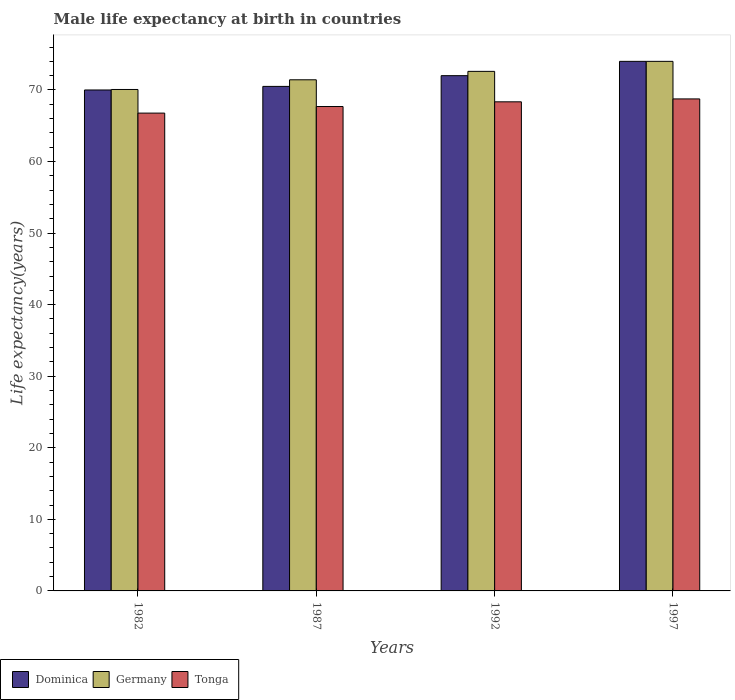How many different coloured bars are there?
Make the answer very short. 3. Are the number of bars per tick equal to the number of legend labels?
Offer a very short reply. Yes. What is the male life expectancy at birth in Dominica in 1987?
Keep it short and to the point. 70.5. Across all years, what is the minimum male life expectancy at birth in Germany?
Give a very brief answer. 70.07. In which year was the male life expectancy at birth in Dominica minimum?
Offer a very short reply. 1982. What is the total male life expectancy at birth in Tonga in the graph?
Offer a terse response. 271.55. What is the difference between the male life expectancy at birth in Germany in 1982 and the male life expectancy at birth in Tonga in 1987?
Give a very brief answer. 2.38. What is the average male life expectancy at birth in Dominica per year?
Ensure brevity in your answer.  71.62. In the year 1992, what is the difference between the male life expectancy at birth in Germany and male life expectancy at birth in Tonga?
Give a very brief answer. 4.25. What is the ratio of the male life expectancy at birth in Tonga in 1987 to that in 1992?
Your response must be concise. 0.99. Is the male life expectancy at birth in Dominica in 1992 less than that in 1997?
Provide a short and direct response. Yes. What is the difference between the highest and the second highest male life expectancy at birth in Germany?
Your answer should be compact. 1.4. What is the difference between the highest and the lowest male life expectancy at birth in Germany?
Your answer should be very brief. 3.93. What does the 1st bar from the left in 1982 represents?
Your answer should be compact. Dominica. How many bars are there?
Make the answer very short. 12. How many years are there in the graph?
Your answer should be very brief. 4. What is the difference between two consecutive major ticks on the Y-axis?
Your response must be concise. 10. Are the values on the major ticks of Y-axis written in scientific E-notation?
Provide a succinct answer. No. Does the graph contain any zero values?
Your answer should be very brief. No. Where does the legend appear in the graph?
Provide a succinct answer. Bottom left. How many legend labels are there?
Offer a terse response. 3. How are the legend labels stacked?
Make the answer very short. Horizontal. What is the title of the graph?
Your answer should be compact. Male life expectancy at birth in countries. What is the label or title of the Y-axis?
Provide a succinct answer. Life expectancy(years). What is the Life expectancy(years) of Germany in 1982?
Ensure brevity in your answer.  70.07. What is the Life expectancy(years) in Tonga in 1982?
Keep it short and to the point. 66.77. What is the Life expectancy(years) in Dominica in 1987?
Your response must be concise. 70.5. What is the Life expectancy(years) of Germany in 1987?
Offer a very short reply. 71.42. What is the Life expectancy(years) of Tonga in 1987?
Make the answer very short. 67.69. What is the Life expectancy(years) in Germany in 1992?
Ensure brevity in your answer.  72.6. What is the Life expectancy(years) in Tonga in 1992?
Give a very brief answer. 68.35. What is the Life expectancy(years) in Dominica in 1997?
Offer a very short reply. 74. What is the Life expectancy(years) of Tonga in 1997?
Your answer should be compact. 68.75. Across all years, what is the maximum Life expectancy(years) of Germany?
Provide a short and direct response. 74. Across all years, what is the maximum Life expectancy(years) of Tonga?
Your response must be concise. 68.75. Across all years, what is the minimum Life expectancy(years) of Dominica?
Make the answer very short. 70. Across all years, what is the minimum Life expectancy(years) of Germany?
Provide a short and direct response. 70.07. Across all years, what is the minimum Life expectancy(years) of Tonga?
Offer a terse response. 66.77. What is the total Life expectancy(years) in Dominica in the graph?
Your response must be concise. 286.5. What is the total Life expectancy(years) in Germany in the graph?
Ensure brevity in your answer.  288.09. What is the total Life expectancy(years) of Tonga in the graph?
Offer a very short reply. 271.56. What is the difference between the Life expectancy(years) in Germany in 1982 and that in 1987?
Give a very brief answer. -1.35. What is the difference between the Life expectancy(years) in Tonga in 1982 and that in 1987?
Offer a very short reply. -0.92. What is the difference between the Life expectancy(years) of Dominica in 1982 and that in 1992?
Provide a short and direct response. -2. What is the difference between the Life expectancy(years) in Germany in 1982 and that in 1992?
Provide a succinct answer. -2.53. What is the difference between the Life expectancy(years) in Tonga in 1982 and that in 1992?
Ensure brevity in your answer.  -1.58. What is the difference between the Life expectancy(years) of Dominica in 1982 and that in 1997?
Keep it short and to the point. -4. What is the difference between the Life expectancy(years) in Germany in 1982 and that in 1997?
Your answer should be compact. -3.93. What is the difference between the Life expectancy(years) in Tonga in 1982 and that in 1997?
Your answer should be compact. -1.98. What is the difference between the Life expectancy(years) of Germany in 1987 and that in 1992?
Offer a terse response. -1.18. What is the difference between the Life expectancy(years) of Tonga in 1987 and that in 1992?
Provide a short and direct response. -0.66. What is the difference between the Life expectancy(years) of Germany in 1987 and that in 1997?
Make the answer very short. -2.58. What is the difference between the Life expectancy(years) of Tonga in 1987 and that in 1997?
Your answer should be compact. -1.06. What is the difference between the Life expectancy(years) of Dominica in 1992 and that in 1997?
Give a very brief answer. -2. What is the difference between the Life expectancy(years) in Germany in 1992 and that in 1997?
Offer a terse response. -1.4. What is the difference between the Life expectancy(years) in Tonga in 1992 and that in 1997?
Offer a very short reply. -0.41. What is the difference between the Life expectancy(years) in Dominica in 1982 and the Life expectancy(years) in Germany in 1987?
Your response must be concise. -1.42. What is the difference between the Life expectancy(years) in Dominica in 1982 and the Life expectancy(years) in Tonga in 1987?
Ensure brevity in your answer.  2.31. What is the difference between the Life expectancy(years) of Germany in 1982 and the Life expectancy(years) of Tonga in 1987?
Keep it short and to the point. 2.38. What is the difference between the Life expectancy(years) in Dominica in 1982 and the Life expectancy(years) in Germany in 1992?
Keep it short and to the point. -2.6. What is the difference between the Life expectancy(years) in Dominica in 1982 and the Life expectancy(years) in Tonga in 1992?
Make the answer very short. 1.65. What is the difference between the Life expectancy(years) of Germany in 1982 and the Life expectancy(years) of Tonga in 1992?
Make the answer very short. 1.72. What is the difference between the Life expectancy(years) in Dominica in 1982 and the Life expectancy(years) in Tonga in 1997?
Ensure brevity in your answer.  1.25. What is the difference between the Life expectancy(years) of Germany in 1982 and the Life expectancy(years) of Tonga in 1997?
Your response must be concise. 1.32. What is the difference between the Life expectancy(years) in Dominica in 1987 and the Life expectancy(years) in Germany in 1992?
Give a very brief answer. -2.1. What is the difference between the Life expectancy(years) of Dominica in 1987 and the Life expectancy(years) of Tonga in 1992?
Your response must be concise. 2.15. What is the difference between the Life expectancy(years) in Germany in 1987 and the Life expectancy(years) in Tonga in 1992?
Offer a terse response. 3.08. What is the difference between the Life expectancy(years) in Dominica in 1987 and the Life expectancy(years) in Tonga in 1997?
Keep it short and to the point. 1.75. What is the difference between the Life expectancy(years) in Germany in 1987 and the Life expectancy(years) in Tonga in 1997?
Your answer should be compact. 2.67. What is the difference between the Life expectancy(years) of Dominica in 1992 and the Life expectancy(years) of Germany in 1997?
Offer a terse response. -2. What is the difference between the Life expectancy(years) of Dominica in 1992 and the Life expectancy(years) of Tonga in 1997?
Provide a succinct answer. 3.25. What is the difference between the Life expectancy(years) of Germany in 1992 and the Life expectancy(years) of Tonga in 1997?
Make the answer very short. 3.85. What is the average Life expectancy(years) of Dominica per year?
Give a very brief answer. 71.62. What is the average Life expectancy(years) in Germany per year?
Offer a very short reply. 72.02. What is the average Life expectancy(years) of Tonga per year?
Keep it short and to the point. 67.89. In the year 1982, what is the difference between the Life expectancy(years) in Dominica and Life expectancy(years) in Germany?
Offer a very short reply. -0.07. In the year 1982, what is the difference between the Life expectancy(years) in Dominica and Life expectancy(years) in Tonga?
Your answer should be very brief. 3.23. In the year 1982, what is the difference between the Life expectancy(years) in Germany and Life expectancy(years) in Tonga?
Offer a very short reply. 3.3. In the year 1987, what is the difference between the Life expectancy(years) of Dominica and Life expectancy(years) of Germany?
Keep it short and to the point. -0.92. In the year 1987, what is the difference between the Life expectancy(years) of Dominica and Life expectancy(years) of Tonga?
Give a very brief answer. 2.81. In the year 1987, what is the difference between the Life expectancy(years) in Germany and Life expectancy(years) in Tonga?
Your response must be concise. 3.73. In the year 1992, what is the difference between the Life expectancy(years) of Dominica and Life expectancy(years) of Germany?
Offer a terse response. -0.6. In the year 1992, what is the difference between the Life expectancy(years) of Dominica and Life expectancy(years) of Tonga?
Make the answer very short. 3.65. In the year 1992, what is the difference between the Life expectancy(years) of Germany and Life expectancy(years) of Tonga?
Your answer should be very brief. 4.25. In the year 1997, what is the difference between the Life expectancy(years) in Dominica and Life expectancy(years) in Tonga?
Ensure brevity in your answer.  5.25. In the year 1997, what is the difference between the Life expectancy(years) in Germany and Life expectancy(years) in Tonga?
Keep it short and to the point. 5.25. What is the ratio of the Life expectancy(years) in Dominica in 1982 to that in 1987?
Offer a terse response. 0.99. What is the ratio of the Life expectancy(years) of Germany in 1982 to that in 1987?
Keep it short and to the point. 0.98. What is the ratio of the Life expectancy(years) of Tonga in 1982 to that in 1987?
Ensure brevity in your answer.  0.99. What is the ratio of the Life expectancy(years) of Dominica in 1982 to that in 1992?
Your answer should be very brief. 0.97. What is the ratio of the Life expectancy(years) of Germany in 1982 to that in 1992?
Give a very brief answer. 0.97. What is the ratio of the Life expectancy(years) in Tonga in 1982 to that in 1992?
Give a very brief answer. 0.98. What is the ratio of the Life expectancy(years) of Dominica in 1982 to that in 1997?
Keep it short and to the point. 0.95. What is the ratio of the Life expectancy(years) in Germany in 1982 to that in 1997?
Your answer should be very brief. 0.95. What is the ratio of the Life expectancy(years) of Tonga in 1982 to that in 1997?
Give a very brief answer. 0.97. What is the ratio of the Life expectancy(years) of Dominica in 1987 to that in 1992?
Offer a terse response. 0.98. What is the ratio of the Life expectancy(years) of Germany in 1987 to that in 1992?
Your response must be concise. 0.98. What is the ratio of the Life expectancy(years) in Tonga in 1987 to that in 1992?
Provide a short and direct response. 0.99. What is the ratio of the Life expectancy(years) in Dominica in 1987 to that in 1997?
Provide a short and direct response. 0.95. What is the ratio of the Life expectancy(years) in Germany in 1987 to that in 1997?
Offer a very short reply. 0.97. What is the ratio of the Life expectancy(years) in Tonga in 1987 to that in 1997?
Keep it short and to the point. 0.98. What is the ratio of the Life expectancy(years) in Germany in 1992 to that in 1997?
Your response must be concise. 0.98. What is the ratio of the Life expectancy(years) in Tonga in 1992 to that in 1997?
Your answer should be very brief. 0.99. What is the difference between the highest and the second highest Life expectancy(years) of Germany?
Offer a terse response. 1.4. What is the difference between the highest and the second highest Life expectancy(years) of Tonga?
Your answer should be very brief. 0.41. What is the difference between the highest and the lowest Life expectancy(years) in Dominica?
Give a very brief answer. 4. What is the difference between the highest and the lowest Life expectancy(years) in Germany?
Keep it short and to the point. 3.93. What is the difference between the highest and the lowest Life expectancy(years) in Tonga?
Keep it short and to the point. 1.98. 